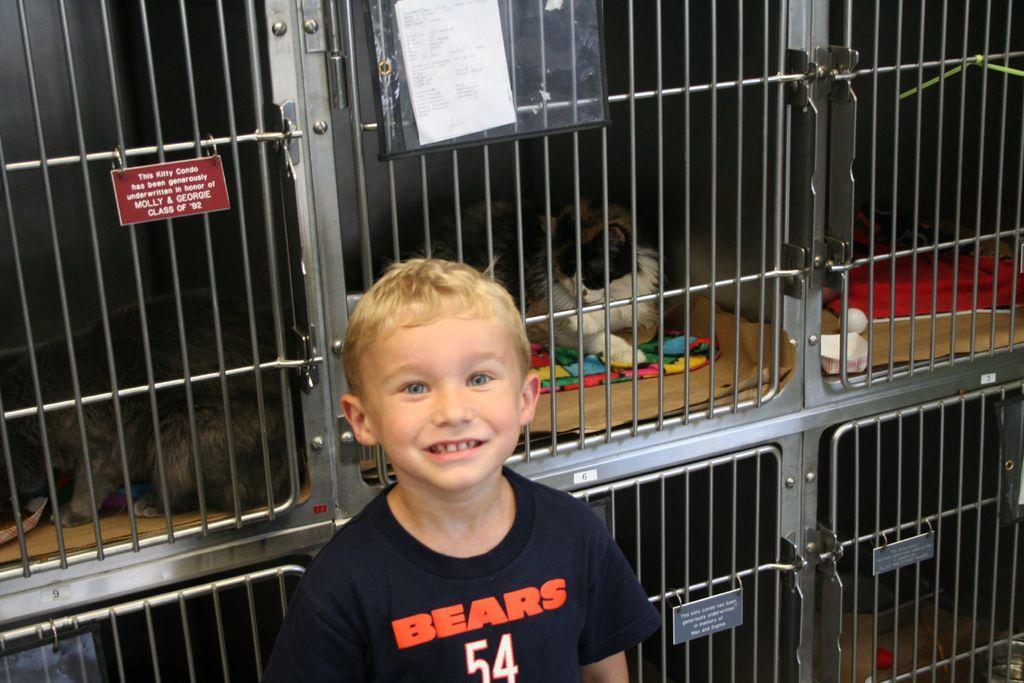Can you describe this image briefly? In this picture we can see a kid standing here, in the background there are some changes, we can see two cats here, there is a board here, we can see a paper posted here. 